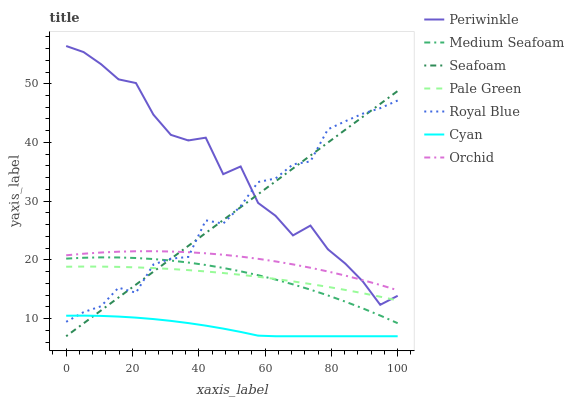Does Cyan have the minimum area under the curve?
Answer yes or no. Yes. Does Periwinkle have the maximum area under the curve?
Answer yes or no. Yes. Does Royal Blue have the minimum area under the curve?
Answer yes or no. No. Does Royal Blue have the maximum area under the curve?
Answer yes or no. No. Is Seafoam the smoothest?
Answer yes or no. Yes. Is Periwinkle the roughest?
Answer yes or no. Yes. Is Royal Blue the smoothest?
Answer yes or no. No. Is Royal Blue the roughest?
Answer yes or no. No. Does Royal Blue have the lowest value?
Answer yes or no. No. Does Royal Blue have the highest value?
Answer yes or no. No. Is Pale Green less than Orchid?
Answer yes or no. Yes. Is Orchid greater than Cyan?
Answer yes or no. Yes. Does Pale Green intersect Orchid?
Answer yes or no. No. 